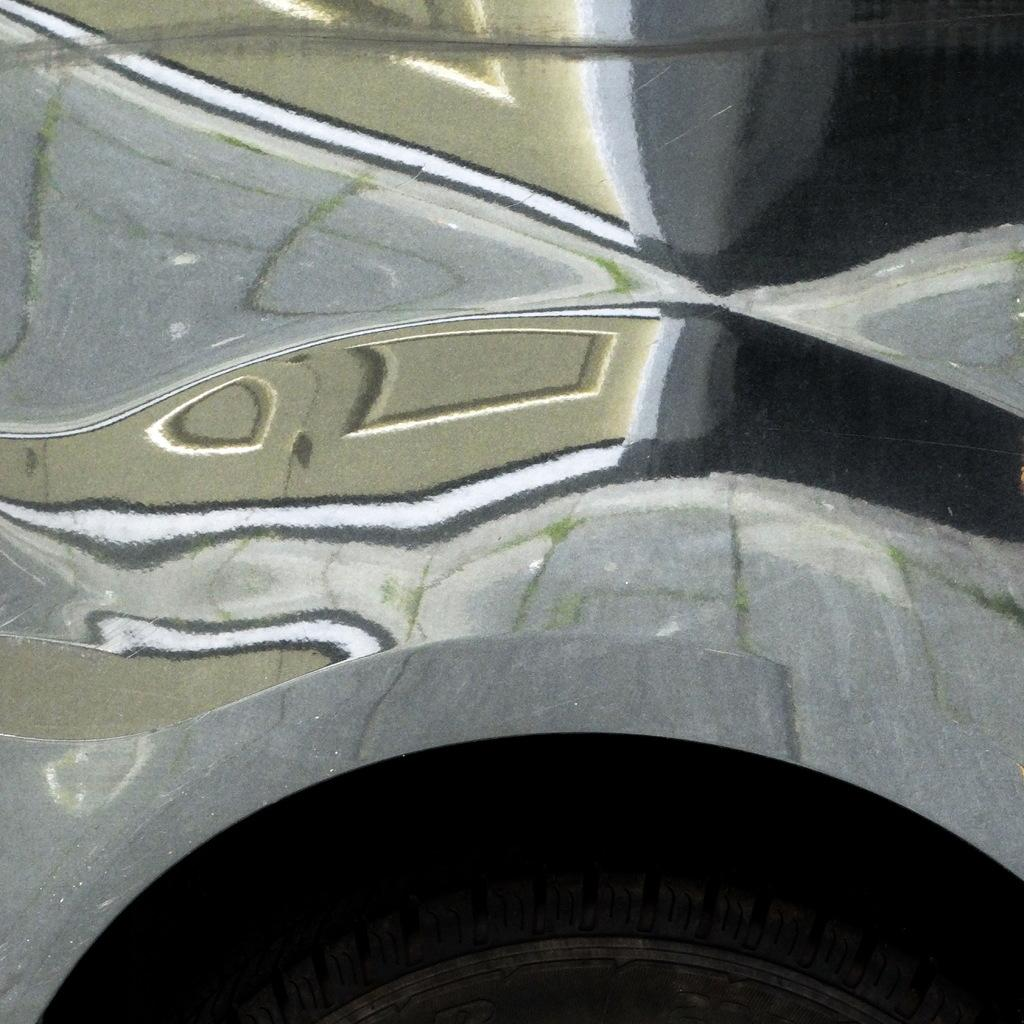What is the main subject in the center of the image? There is a vehicle in the center of the image. Can you describe any specific features of the vehicle? Unfortunately, the provided facts do not mention any specific features of the vehicle. What is located at the bottom of the image? There is a tire at the bottom of the image. What type of crime is being committed in the image? There is no indication of any crime being committed in the image; it features a vehicle and a tire. How much zinc is present in the image? There is no mention of zinc in the image, so it is impossible to determine its presence or quantity. 